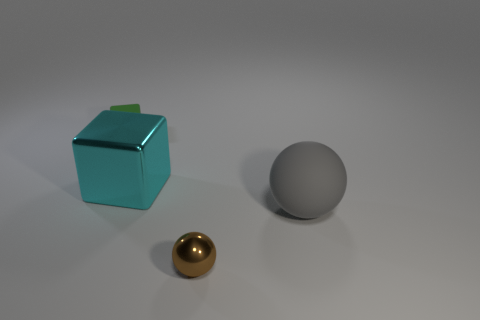Add 4 small shiny things. How many objects exist? 8 Subtract 1 spheres. How many spheres are left? 1 Subtract all blue cylinders. How many green blocks are left? 1 Subtract all large cyan shiny things. Subtract all big metallic things. How many objects are left? 2 Add 4 large matte spheres. How many large matte spheres are left? 5 Add 2 tiny cyan rubber objects. How many tiny cyan rubber objects exist? 2 Subtract all brown balls. How many balls are left? 1 Subtract 0 cyan cylinders. How many objects are left? 4 Subtract all gray balls. Subtract all red blocks. How many balls are left? 1 